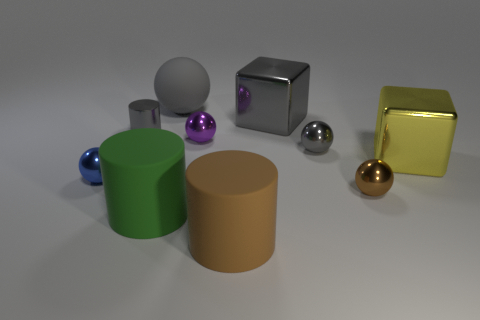Subtract all cylinders. How many objects are left? 7 Subtract 2 blocks. How many blocks are left? 0 Subtract all metallic cylinders. How many cylinders are left? 2 Subtract all yellow blocks. Subtract all gray spheres. How many blocks are left? 1 Subtract all cyan balls. How many gray cubes are left? 1 Subtract all big cyan cylinders. Subtract all green objects. How many objects are left? 9 Add 6 big yellow objects. How many big yellow objects are left? 7 Add 1 shiny cylinders. How many shiny cylinders exist? 2 Subtract all gray blocks. How many blocks are left? 1 Subtract 0 purple cubes. How many objects are left? 10 